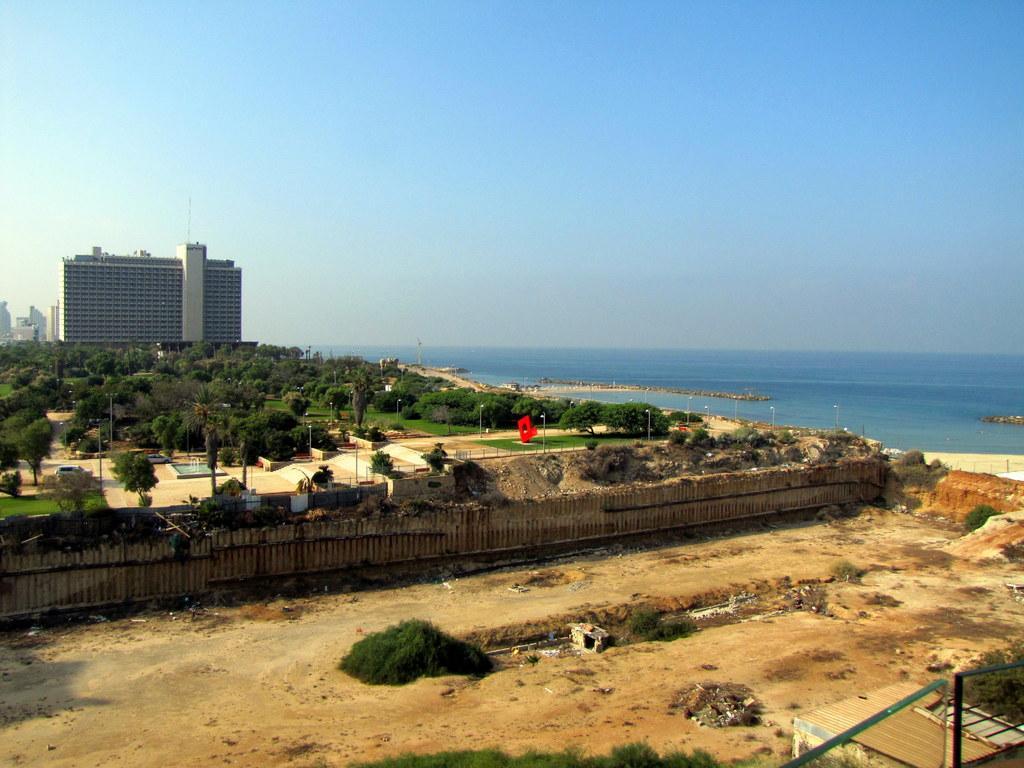Could you give a brief overview of what you see in this image? In the picture I can see the buildings on the left side. I can see the trees, light poles and wooden fence. I can see a car and swimming pool on the left side. I can see the ocean on the right side. There are clouds in the sky. 